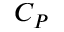<formula> <loc_0><loc_0><loc_500><loc_500>C _ { P }</formula> 